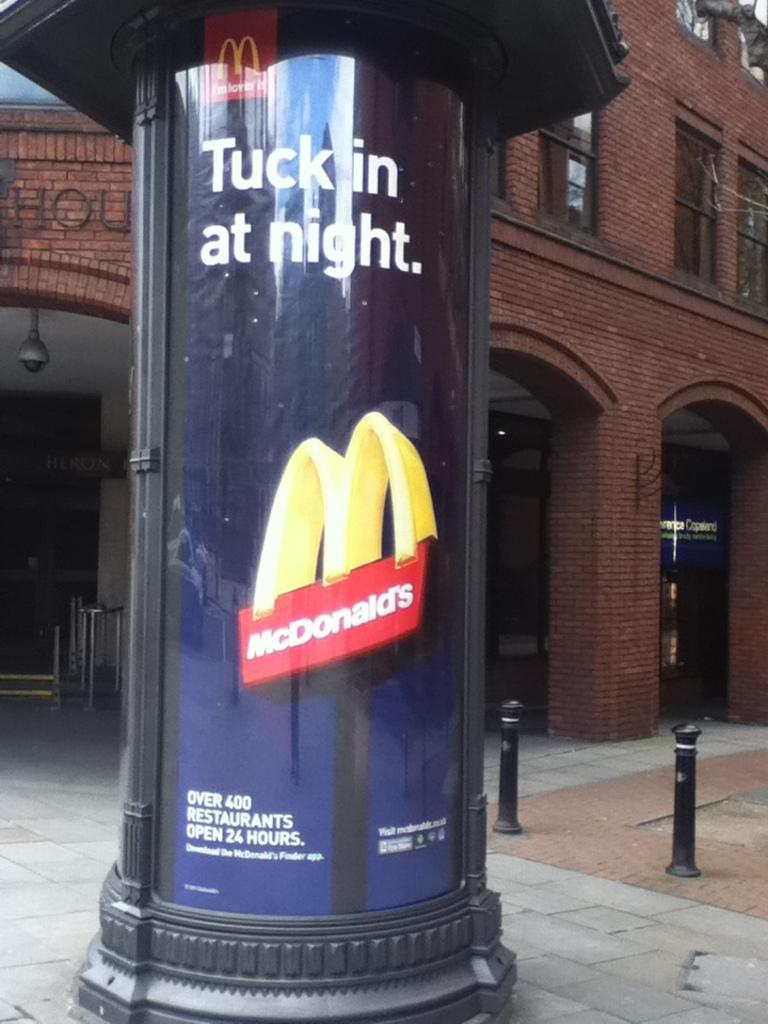What type of structure is present in the image? There is a telephone booth in the image. What material is used for the rods in the image? The rods in the image are made of metal. What can be seen in the background of the image? There is a building in the background of the image. What type of wealth is displayed on the telephone booth in the image? There is no wealth displayed on the telephone booth in the image. What type of drug can be seen in the image? There is no drug present in the image. 